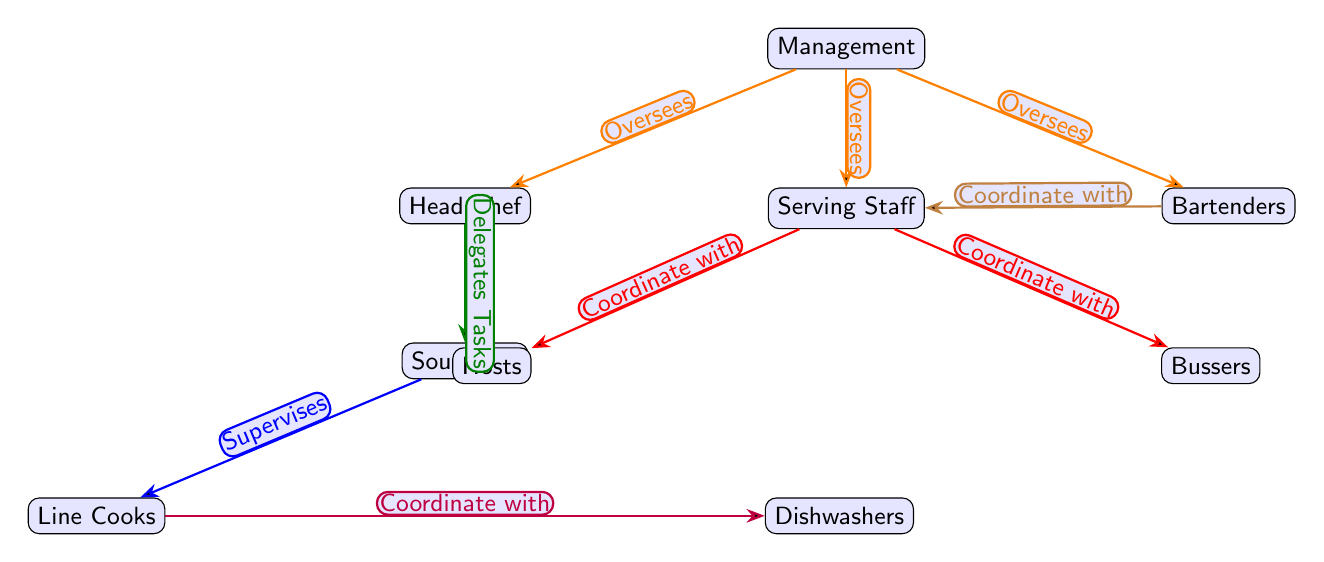What is the top node of the diagram? The top node represents the "Management" of the establishment, which oversees the various roles within the restaurant.
Answer: Management How many serving-related roles are shown in the diagram? There are three roles specifically related to serving: "Serving Staff," "Hosts," and "Bussers." Counting these roles gives us a total of three.
Answer: 3 What type of relationship connects the Head Chef and Sous Chef? The diagram illustrates that the Head Chef "Delegates Tasks" to the Sous Chef, indicating a hierarchy in task distribution within the kitchen.
Answer: Delegates Tasks Who supervises the Line Cooks? The diagram shows that the "Sous Chef" is responsible for supervising the Line Cooks, demonstrating a direct supervisor role.
Answer: Sous Chef What color represents the relationship between serving staff and hosts? The relationship between the Serving Staff and Hosts is colored in red, which depicts a specific type of coordination flow in the diagram.
Answer: Red Which node does not coordinate with any others? When examining the diagram, all roles appear to coordinate or oversee others, but "Management" only oversees other roles and does not coordinate directly with any specific operational personnel.
Answer: Management How many total nodes are present in the diagram? By counting each role, including Management and all subordinate positions, we find there are ten nodes total in the diagram structure.
Answer: 10 What is the relationship between Bartenders and Serving Staff? The diagram indicates that Bartenders "Coordinate with" Serving Staff, which is essential for ensuring that drink service aligns with the overall service.
Answer: Coordinate with Which role is depicted as coordinating with both Hosts and Bussers? The "Serving Staff" role is shown to coordinate with both Hosts and Bussers, highlighting its central position in service management during events.
Answer: Serving Staff What does the color orange signify in this diagram? The color orange represents oversight relationships in the diagram, specifically the connections between Management and the various roles such as the Head Chef, Serving Staff, and Bartenders.
Answer: Oversees 